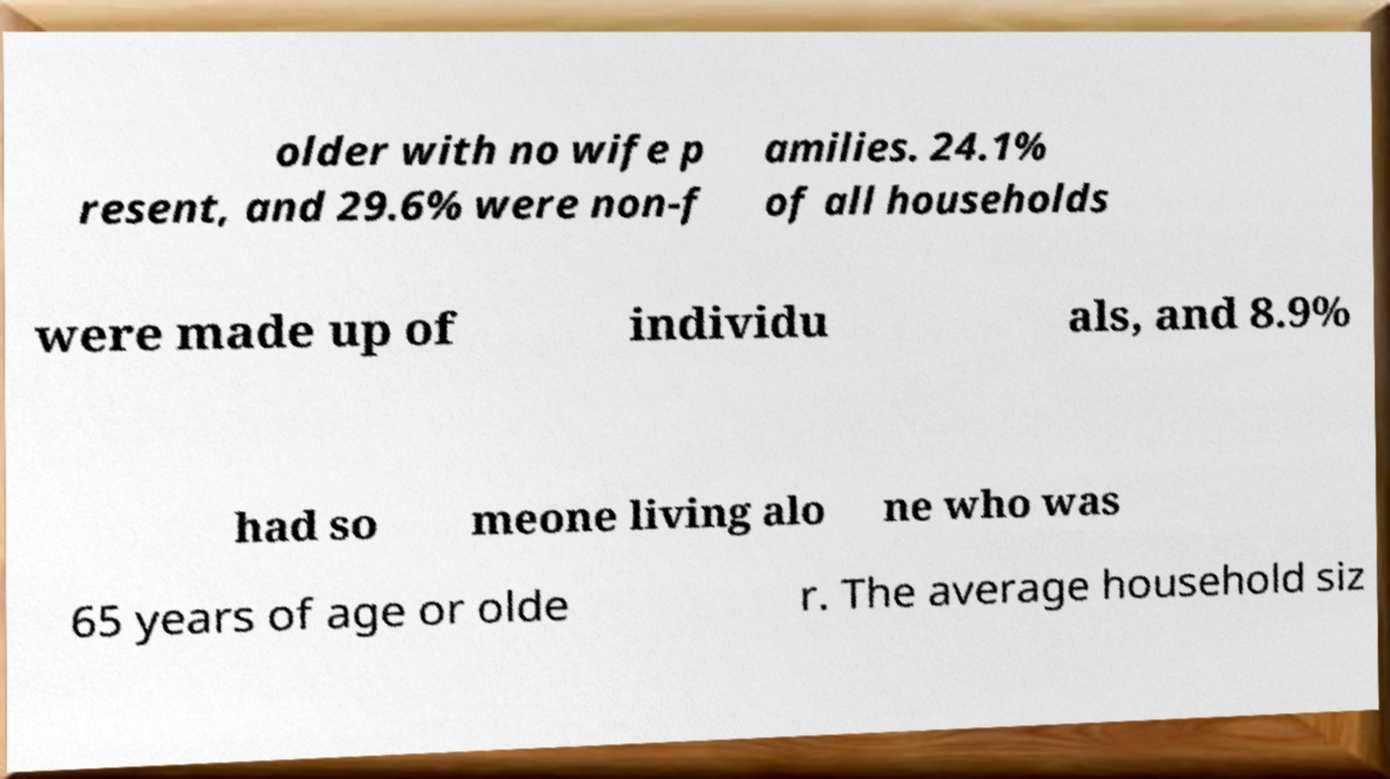Could you assist in decoding the text presented in this image and type it out clearly? older with no wife p resent, and 29.6% were non-f amilies. 24.1% of all households were made up of individu als, and 8.9% had so meone living alo ne who was 65 years of age or olde r. The average household siz 